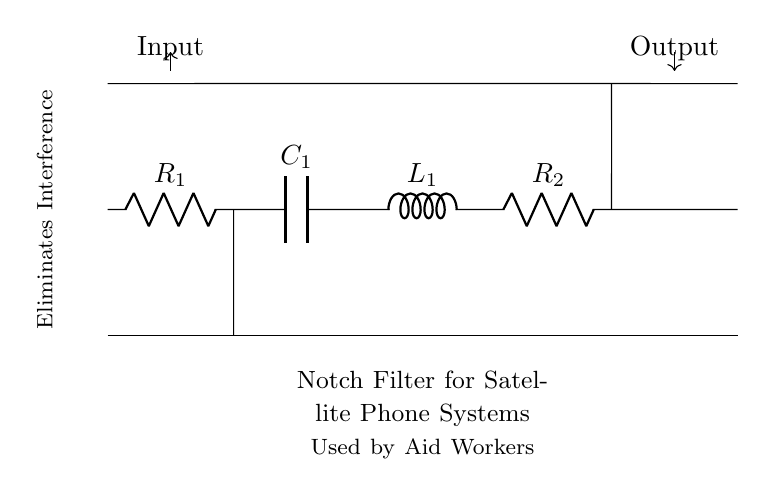What type of filter is shown in the diagram? The circuit is a notch filter, which is specifically designed to eliminate particular frequencies of interference. The text in the diagram states "Notch Filter for Satellite Phone Systems," confirming this.
Answer: Notch filter How many resistors are in the circuit? The circuit includes two resistors identified as R1 and R2. Each component in the diagram is labeled, and the number of resistors can be directly counted.
Answer: Two What is the purpose of the capacitor in this circuit? The capacitor, labeled as C1, plays a crucial role in filtering out certain frequency components of the input signal, helping to set the notch frequency alongside the other components.
Answer: Filtering interference Which component directly connects the circuit to the input signal? The input signal connects to the circuit at point 'Input,' indicated by the labeled arrow in the diagram. The connection is made at the top of the circuit, where the signal enters.
Answer: Resistor R1 What is the function of the inductor in the notch filter? The inductor, labeled as L1, works together with the rest of the circuit components to create a notch at a specific frequency, ensuring that unwanted signals are attenuated while allowing desired frequencies to pass.
Answer: Create notch frequency What indicates the flow direction of the signal in the circuit? The arrows labeled "Input" and "Output" at the top and bottom of the circuit diagram indicate the direction of signal flow. The input flows into the circuit, and the output is where the processed signal exits.
Answer: Arrows What are the labeled values of the components in the circuit? The circuit displays the labels R1, R2 for resistors, C1 for the capacitor, and L1 for the inductor, which represent their respective roles in the notch filter design. While no numerical values are provided, the types of components are clearly labeled.
Answer: R1, R2, C1, L1 